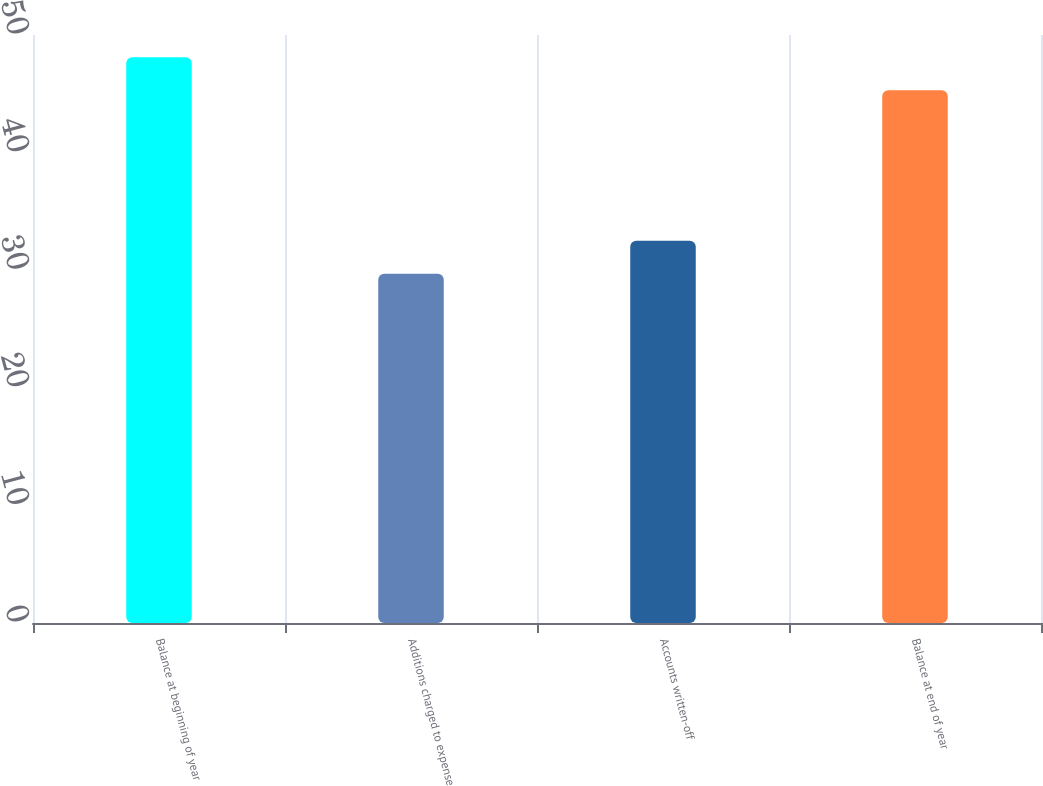<chart> <loc_0><loc_0><loc_500><loc_500><bar_chart><fcel>Balance at beginning of year<fcel>Additions charged to expense<fcel>Accounts written-off<fcel>Balance at end of year<nl><fcel>48.1<fcel>29.7<fcel>32.5<fcel>45.3<nl></chart> 